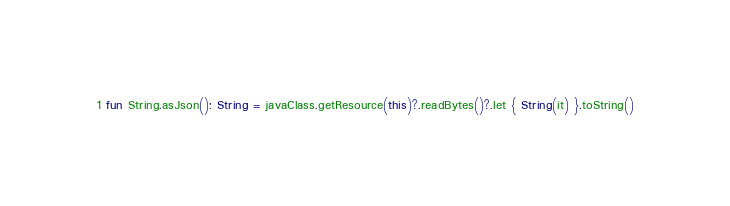Convert code to text. <code><loc_0><loc_0><loc_500><loc_500><_Kotlin_>
fun String.asJson(): String = javaClass.getResource(this)?.readBytes()?.let { String(it) }.toString()</code> 